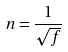Convert formula to latex. <formula><loc_0><loc_0><loc_500><loc_500>n = \frac { 1 } { \sqrt { f } }</formula> 